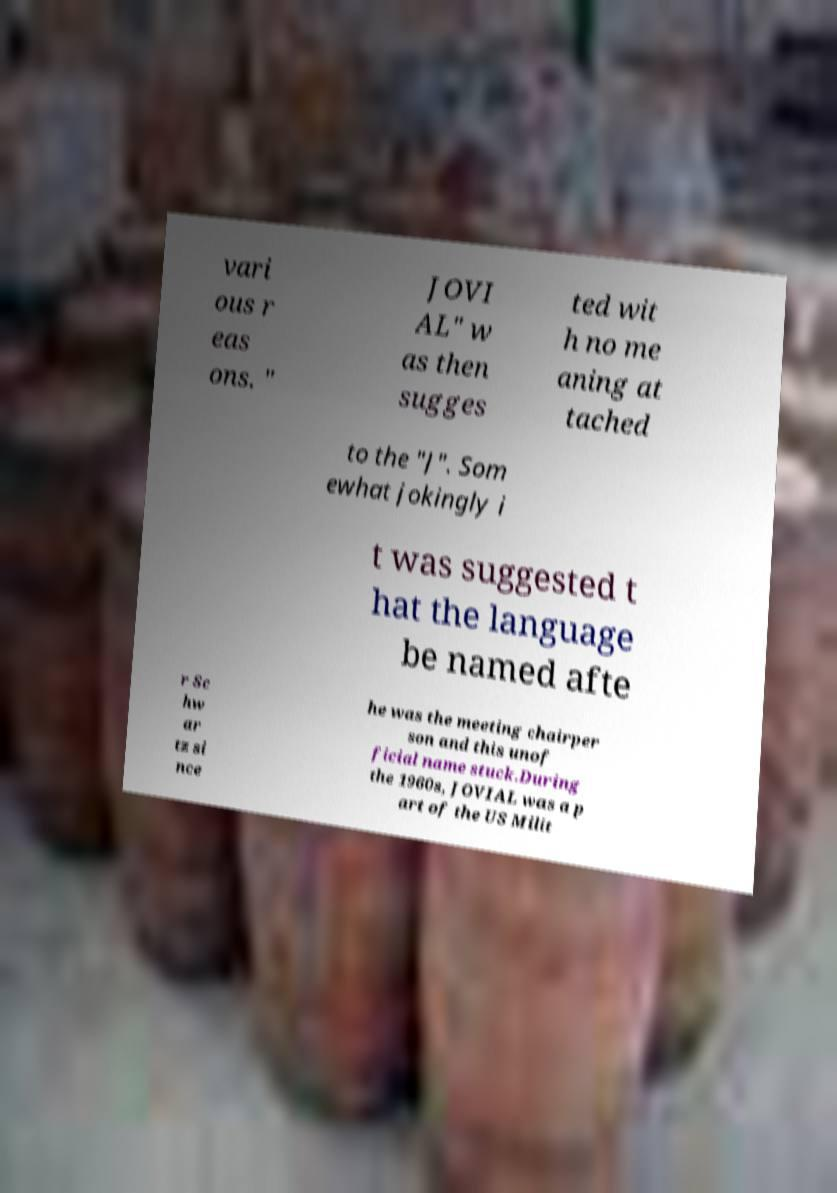Could you extract and type out the text from this image? vari ous r eas ons. " JOVI AL" w as then sugges ted wit h no me aning at tached to the "J". Som ewhat jokingly i t was suggested t hat the language be named afte r Sc hw ar tz si nce he was the meeting chairper son and this unof ficial name stuck.During the 1960s, JOVIAL was a p art of the US Milit 